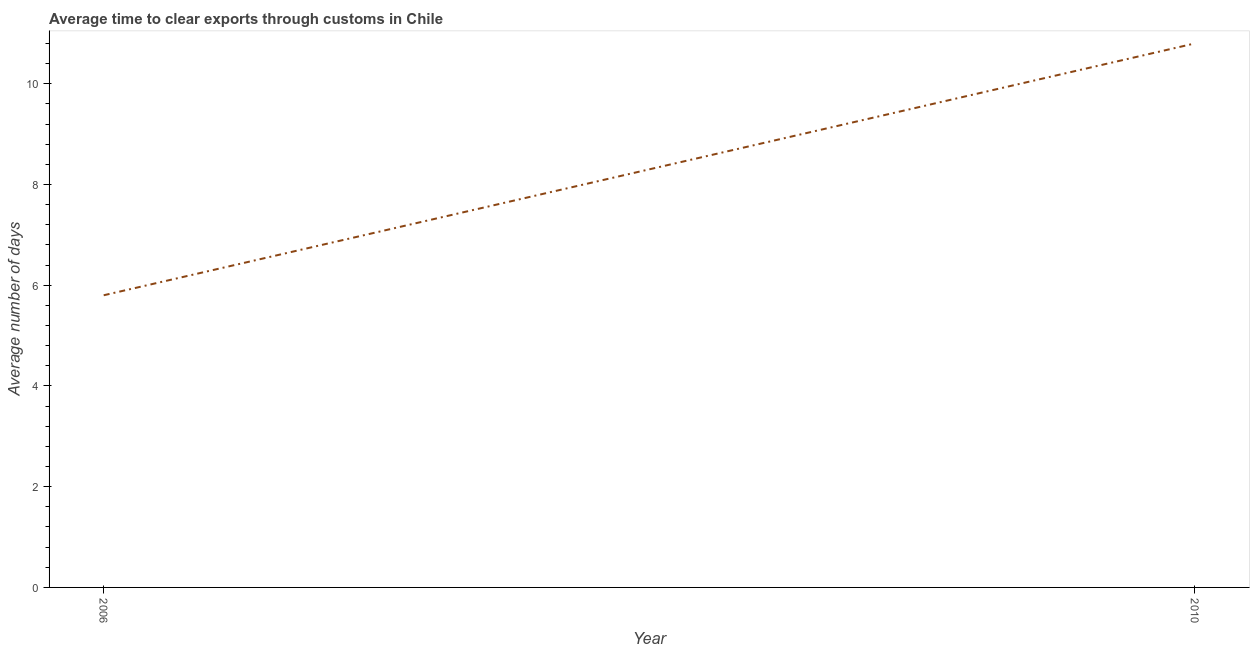What is the difference between the time to clear exports through customs in 2006 and 2010?
Offer a terse response. -5. Do a majority of the years between 2010 and 2006 (inclusive) have time to clear exports through customs greater than 4 days?
Give a very brief answer. No. What is the ratio of the time to clear exports through customs in 2006 to that in 2010?
Your answer should be compact. 0.54. Is the time to clear exports through customs in 2006 less than that in 2010?
Your answer should be very brief. Yes. Does the time to clear exports through customs monotonically increase over the years?
Keep it short and to the point. Yes. How many lines are there?
Offer a terse response. 1. How many years are there in the graph?
Keep it short and to the point. 2. Does the graph contain any zero values?
Your answer should be very brief. No. Does the graph contain grids?
Keep it short and to the point. No. What is the title of the graph?
Give a very brief answer. Average time to clear exports through customs in Chile. What is the label or title of the Y-axis?
Your response must be concise. Average number of days. What is the Average number of days in 2010?
Provide a succinct answer. 10.8. What is the ratio of the Average number of days in 2006 to that in 2010?
Make the answer very short. 0.54. 